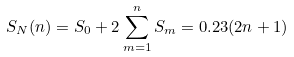<formula> <loc_0><loc_0><loc_500><loc_500>S _ { N } ( n ) = S _ { 0 } + 2 \sum _ { m = 1 } ^ { n } S _ { m } = 0 . 2 3 ( 2 n + 1 )</formula> 